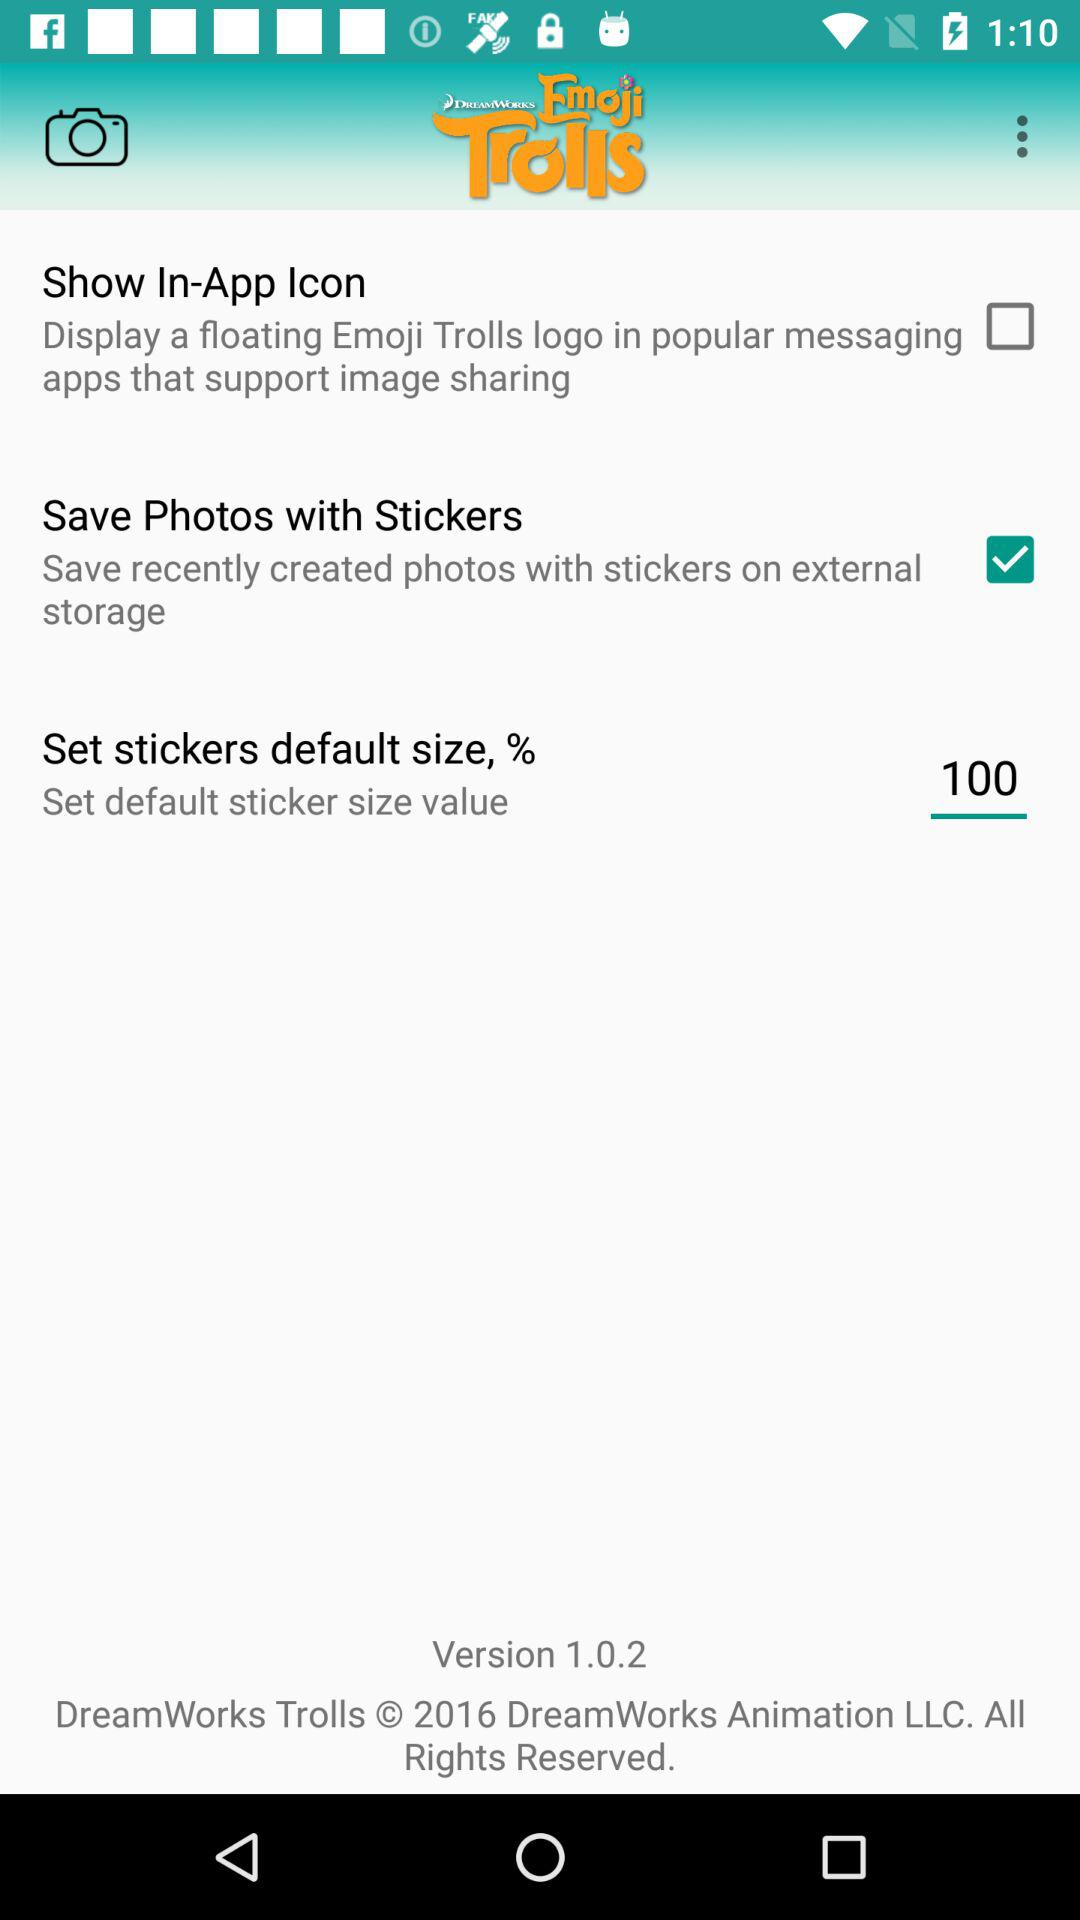How many percent is the default sticker size set to?
Answer the question using a single word or phrase. 100 